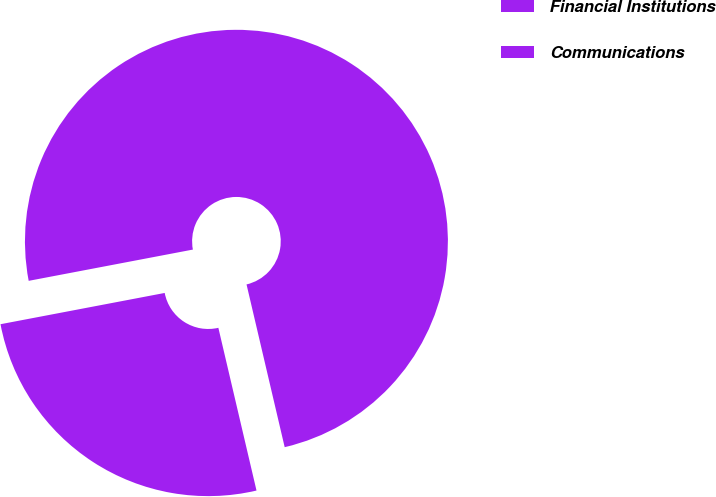<chart> <loc_0><loc_0><loc_500><loc_500><pie_chart><fcel>Financial Institutions<fcel>Communications<nl><fcel>74.33%<fcel>25.67%<nl></chart> 